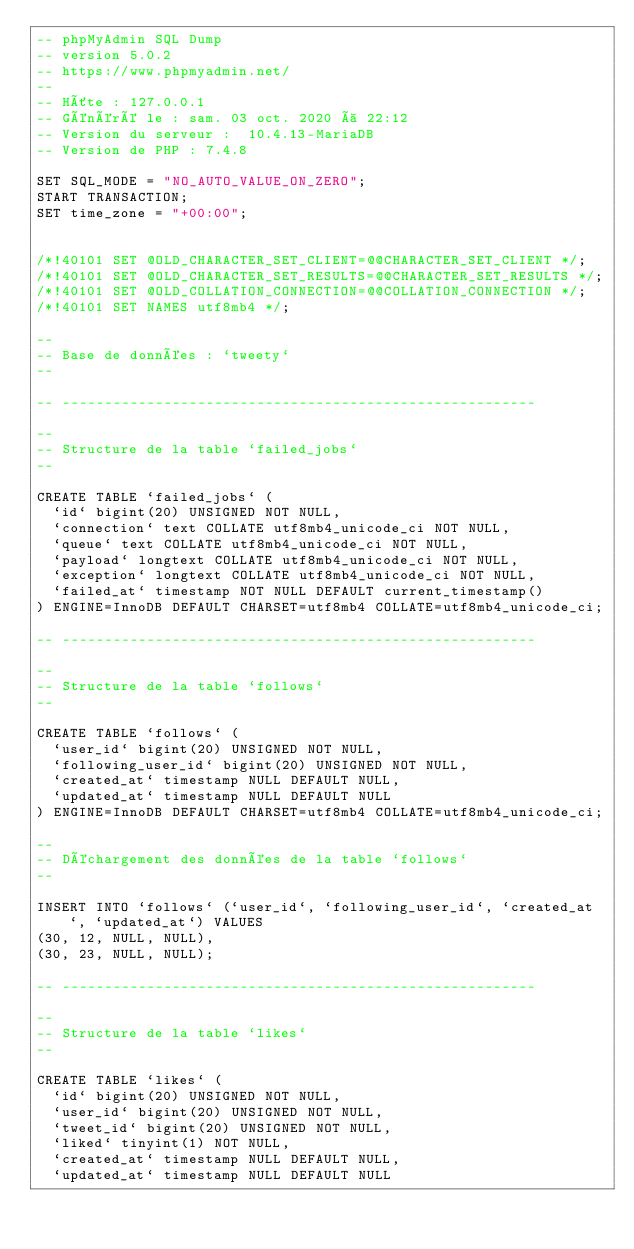<code> <loc_0><loc_0><loc_500><loc_500><_SQL_>-- phpMyAdmin SQL Dump
-- version 5.0.2
-- https://www.phpmyadmin.net/
--
-- Hôte : 127.0.0.1
-- Généré le : sam. 03 oct. 2020 à 22:12
-- Version du serveur :  10.4.13-MariaDB
-- Version de PHP : 7.4.8

SET SQL_MODE = "NO_AUTO_VALUE_ON_ZERO";
START TRANSACTION;
SET time_zone = "+00:00";


/*!40101 SET @OLD_CHARACTER_SET_CLIENT=@@CHARACTER_SET_CLIENT */;
/*!40101 SET @OLD_CHARACTER_SET_RESULTS=@@CHARACTER_SET_RESULTS */;
/*!40101 SET @OLD_COLLATION_CONNECTION=@@COLLATION_CONNECTION */;
/*!40101 SET NAMES utf8mb4 */;

--
-- Base de données : `tweety`
--

-- --------------------------------------------------------

--
-- Structure de la table `failed_jobs`
--

CREATE TABLE `failed_jobs` (
  `id` bigint(20) UNSIGNED NOT NULL,
  `connection` text COLLATE utf8mb4_unicode_ci NOT NULL,
  `queue` text COLLATE utf8mb4_unicode_ci NOT NULL,
  `payload` longtext COLLATE utf8mb4_unicode_ci NOT NULL,
  `exception` longtext COLLATE utf8mb4_unicode_ci NOT NULL,
  `failed_at` timestamp NOT NULL DEFAULT current_timestamp()
) ENGINE=InnoDB DEFAULT CHARSET=utf8mb4 COLLATE=utf8mb4_unicode_ci;

-- --------------------------------------------------------

--
-- Structure de la table `follows`
--

CREATE TABLE `follows` (
  `user_id` bigint(20) UNSIGNED NOT NULL,
  `following_user_id` bigint(20) UNSIGNED NOT NULL,
  `created_at` timestamp NULL DEFAULT NULL,
  `updated_at` timestamp NULL DEFAULT NULL
) ENGINE=InnoDB DEFAULT CHARSET=utf8mb4 COLLATE=utf8mb4_unicode_ci;

--
-- Déchargement des données de la table `follows`
--

INSERT INTO `follows` (`user_id`, `following_user_id`, `created_at`, `updated_at`) VALUES
(30, 12, NULL, NULL),
(30, 23, NULL, NULL);

-- --------------------------------------------------------

--
-- Structure de la table `likes`
--

CREATE TABLE `likes` (
  `id` bigint(20) UNSIGNED NOT NULL,
  `user_id` bigint(20) UNSIGNED NOT NULL,
  `tweet_id` bigint(20) UNSIGNED NOT NULL,
  `liked` tinyint(1) NOT NULL,
  `created_at` timestamp NULL DEFAULT NULL,
  `updated_at` timestamp NULL DEFAULT NULL</code> 